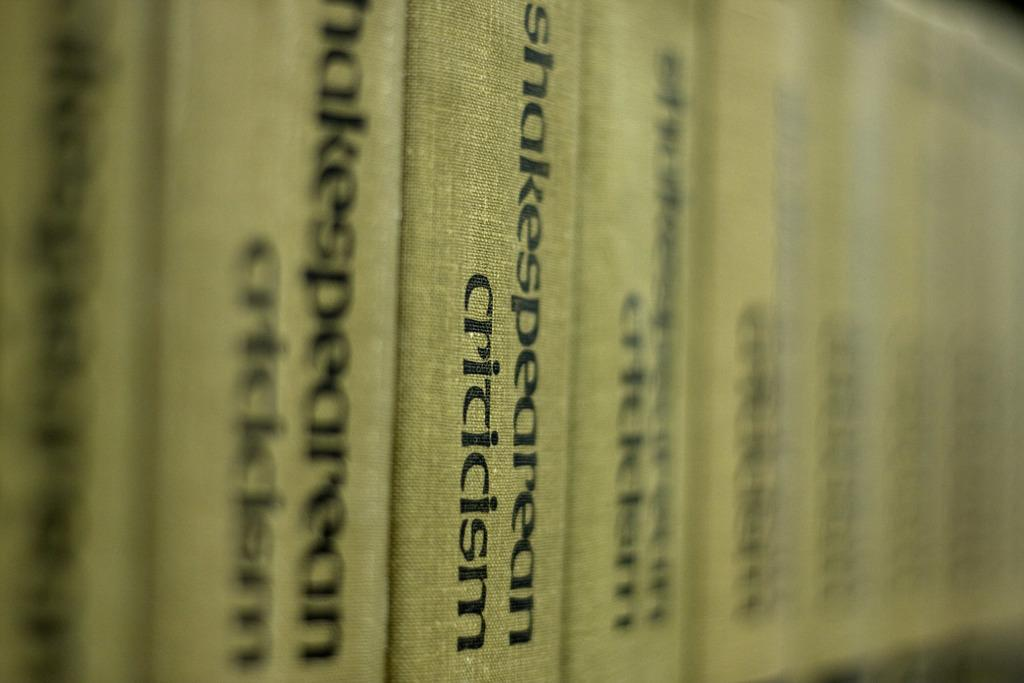<image>
Describe the image concisely. A line of books with the title Shakespearean Criticism. 